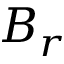<formula> <loc_0><loc_0><loc_500><loc_500>B _ { r }</formula> 